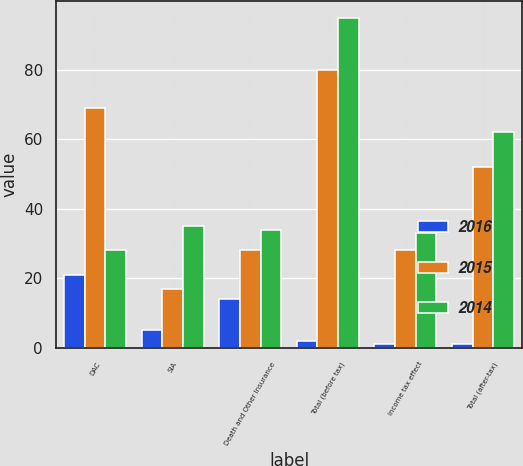Convert chart. <chart><loc_0><loc_0><loc_500><loc_500><stacked_bar_chart><ecel><fcel>DAC<fcel>SIA<fcel>Death and Other Insurance<fcel>Total (before tax)<fcel>Income tax effect<fcel>Total (after-tax)<nl><fcel>2016<fcel>21<fcel>5<fcel>14<fcel>2<fcel>1<fcel>1<nl><fcel>2015<fcel>69<fcel>17<fcel>28<fcel>80<fcel>28<fcel>52<nl><fcel>2014<fcel>28<fcel>35<fcel>34<fcel>95<fcel>33<fcel>62<nl></chart> 